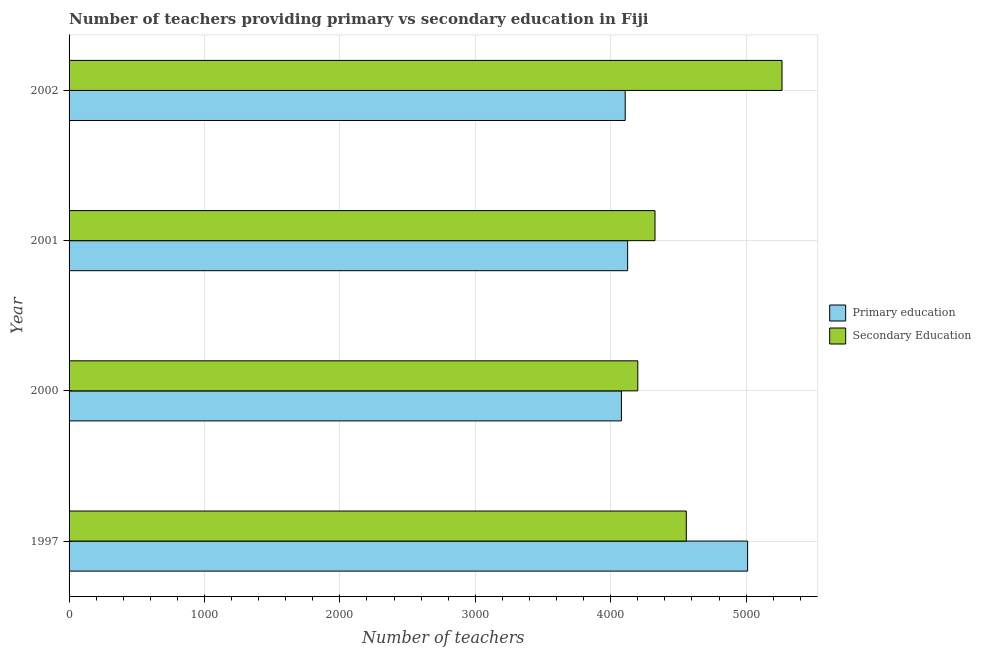How many different coloured bars are there?
Offer a very short reply. 2. How many groups of bars are there?
Ensure brevity in your answer.  4. Are the number of bars per tick equal to the number of legend labels?
Make the answer very short. Yes. Are the number of bars on each tick of the Y-axis equal?
Your answer should be compact. Yes. What is the label of the 3rd group of bars from the top?
Give a very brief answer. 2000. In how many cases, is the number of bars for a given year not equal to the number of legend labels?
Provide a short and direct response. 0. What is the number of primary teachers in 2001?
Your answer should be very brief. 4125. Across all years, what is the maximum number of secondary teachers?
Your answer should be very brief. 5265. Across all years, what is the minimum number of primary teachers?
Make the answer very short. 4079. What is the total number of primary teachers in the graph?
Give a very brief answer. 1.73e+04. What is the difference between the number of primary teachers in 2000 and that in 2001?
Offer a very short reply. -46. What is the difference between the number of secondary teachers in 2000 and the number of primary teachers in 2002?
Your answer should be very brief. 93. What is the average number of primary teachers per year?
Your response must be concise. 4330.5. In the year 2002, what is the difference between the number of secondary teachers and number of primary teachers?
Offer a very short reply. 1158. In how many years, is the number of primary teachers greater than 3400 ?
Ensure brevity in your answer.  4. What is the ratio of the number of primary teachers in 2000 to that in 2001?
Make the answer very short. 0.99. Is the number of secondary teachers in 1997 less than that in 2001?
Your response must be concise. No. Is the difference between the number of primary teachers in 1997 and 2002 greater than the difference between the number of secondary teachers in 1997 and 2002?
Your response must be concise. Yes. What is the difference between the highest and the second highest number of primary teachers?
Give a very brief answer. 886. What is the difference between the highest and the lowest number of secondary teachers?
Keep it short and to the point. 1065. In how many years, is the number of secondary teachers greater than the average number of secondary teachers taken over all years?
Keep it short and to the point. 1. What does the 2nd bar from the top in 2000 represents?
Offer a terse response. Primary education. What does the 2nd bar from the bottom in 2000 represents?
Give a very brief answer. Secondary Education. How many bars are there?
Your response must be concise. 8. Are all the bars in the graph horizontal?
Your answer should be compact. Yes. What is the difference between two consecutive major ticks on the X-axis?
Give a very brief answer. 1000. Are the values on the major ticks of X-axis written in scientific E-notation?
Provide a short and direct response. No. Does the graph contain grids?
Make the answer very short. Yes. What is the title of the graph?
Your answer should be compact. Number of teachers providing primary vs secondary education in Fiji. Does "Savings" appear as one of the legend labels in the graph?
Offer a terse response. No. What is the label or title of the X-axis?
Provide a short and direct response. Number of teachers. What is the label or title of the Y-axis?
Offer a very short reply. Year. What is the Number of teachers of Primary education in 1997?
Make the answer very short. 5011. What is the Number of teachers of Secondary Education in 1997?
Offer a terse response. 4558. What is the Number of teachers of Primary education in 2000?
Make the answer very short. 4079. What is the Number of teachers of Secondary Education in 2000?
Provide a short and direct response. 4200. What is the Number of teachers of Primary education in 2001?
Provide a short and direct response. 4125. What is the Number of teachers of Secondary Education in 2001?
Your answer should be very brief. 4327. What is the Number of teachers in Primary education in 2002?
Provide a short and direct response. 4107. What is the Number of teachers of Secondary Education in 2002?
Keep it short and to the point. 5265. Across all years, what is the maximum Number of teachers of Primary education?
Keep it short and to the point. 5011. Across all years, what is the maximum Number of teachers of Secondary Education?
Your answer should be compact. 5265. Across all years, what is the minimum Number of teachers of Primary education?
Provide a short and direct response. 4079. Across all years, what is the minimum Number of teachers of Secondary Education?
Offer a terse response. 4200. What is the total Number of teachers in Primary education in the graph?
Ensure brevity in your answer.  1.73e+04. What is the total Number of teachers of Secondary Education in the graph?
Provide a succinct answer. 1.84e+04. What is the difference between the Number of teachers of Primary education in 1997 and that in 2000?
Your answer should be compact. 932. What is the difference between the Number of teachers in Secondary Education in 1997 and that in 2000?
Provide a succinct answer. 358. What is the difference between the Number of teachers in Primary education in 1997 and that in 2001?
Give a very brief answer. 886. What is the difference between the Number of teachers in Secondary Education in 1997 and that in 2001?
Offer a very short reply. 231. What is the difference between the Number of teachers in Primary education in 1997 and that in 2002?
Your response must be concise. 904. What is the difference between the Number of teachers in Secondary Education in 1997 and that in 2002?
Ensure brevity in your answer.  -707. What is the difference between the Number of teachers of Primary education in 2000 and that in 2001?
Offer a terse response. -46. What is the difference between the Number of teachers in Secondary Education in 2000 and that in 2001?
Your answer should be very brief. -127. What is the difference between the Number of teachers in Primary education in 2000 and that in 2002?
Your response must be concise. -28. What is the difference between the Number of teachers of Secondary Education in 2000 and that in 2002?
Your response must be concise. -1065. What is the difference between the Number of teachers of Primary education in 2001 and that in 2002?
Ensure brevity in your answer.  18. What is the difference between the Number of teachers of Secondary Education in 2001 and that in 2002?
Ensure brevity in your answer.  -938. What is the difference between the Number of teachers in Primary education in 1997 and the Number of teachers in Secondary Education in 2000?
Give a very brief answer. 811. What is the difference between the Number of teachers of Primary education in 1997 and the Number of teachers of Secondary Education in 2001?
Your answer should be compact. 684. What is the difference between the Number of teachers in Primary education in 1997 and the Number of teachers in Secondary Education in 2002?
Your answer should be compact. -254. What is the difference between the Number of teachers of Primary education in 2000 and the Number of teachers of Secondary Education in 2001?
Your response must be concise. -248. What is the difference between the Number of teachers in Primary education in 2000 and the Number of teachers in Secondary Education in 2002?
Offer a very short reply. -1186. What is the difference between the Number of teachers of Primary education in 2001 and the Number of teachers of Secondary Education in 2002?
Keep it short and to the point. -1140. What is the average Number of teachers of Primary education per year?
Your answer should be very brief. 4330.5. What is the average Number of teachers of Secondary Education per year?
Your answer should be very brief. 4587.5. In the year 1997, what is the difference between the Number of teachers in Primary education and Number of teachers in Secondary Education?
Your answer should be compact. 453. In the year 2000, what is the difference between the Number of teachers of Primary education and Number of teachers of Secondary Education?
Make the answer very short. -121. In the year 2001, what is the difference between the Number of teachers of Primary education and Number of teachers of Secondary Education?
Give a very brief answer. -202. In the year 2002, what is the difference between the Number of teachers in Primary education and Number of teachers in Secondary Education?
Offer a terse response. -1158. What is the ratio of the Number of teachers of Primary education in 1997 to that in 2000?
Your response must be concise. 1.23. What is the ratio of the Number of teachers in Secondary Education in 1997 to that in 2000?
Offer a very short reply. 1.09. What is the ratio of the Number of teachers of Primary education in 1997 to that in 2001?
Your answer should be very brief. 1.21. What is the ratio of the Number of teachers in Secondary Education in 1997 to that in 2001?
Your answer should be very brief. 1.05. What is the ratio of the Number of teachers of Primary education in 1997 to that in 2002?
Provide a short and direct response. 1.22. What is the ratio of the Number of teachers of Secondary Education in 1997 to that in 2002?
Your response must be concise. 0.87. What is the ratio of the Number of teachers of Primary education in 2000 to that in 2001?
Ensure brevity in your answer.  0.99. What is the ratio of the Number of teachers in Secondary Education in 2000 to that in 2001?
Your answer should be compact. 0.97. What is the ratio of the Number of teachers of Primary education in 2000 to that in 2002?
Make the answer very short. 0.99. What is the ratio of the Number of teachers of Secondary Education in 2000 to that in 2002?
Your answer should be compact. 0.8. What is the ratio of the Number of teachers of Primary education in 2001 to that in 2002?
Your answer should be very brief. 1. What is the ratio of the Number of teachers of Secondary Education in 2001 to that in 2002?
Give a very brief answer. 0.82. What is the difference between the highest and the second highest Number of teachers in Primary education?
Give a very brief answer. 886. What is the difference between the highest and the second highest Number of teachers of Secondary Education?
Your response must be concise. 707. What is the difference between the highest and the lowest Number of teachers in Primary education?
Your response must be concise. 932. What is the difference between the highest and the lowest Number of teachers of Secondary Education?
Give a very brief answer. 1065. 